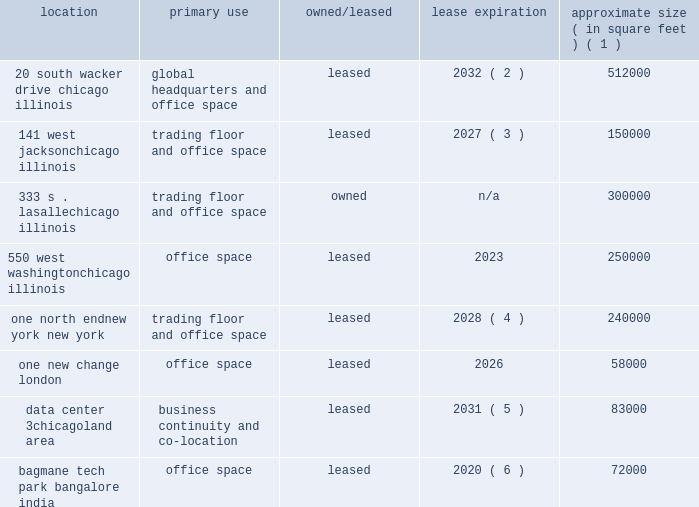Item 1b .
Unresolved staff comments not applicable .
Item 2 .
Properties our global headquarters are located in chicago , illinois , at 20 south wacker drive .
The following is a description of our key locations and facilities .
Location primary use owned/leased lease expiration approximate size ( in square feet ) ( 1 ) 20 south wacker drive chicago , illinois global headquarters and office space leased 2032 ( 2 ) 512000 141 west jackson chicago , illinois trading floor and office space leased 2027 ( 3 ) 150000 333 s .
Lasalle chicago , illinois trading floor and office space owned n/a 300000 550 west washington chicago , illinois office space leased 2023 250000 one north end new york , new york trading floor and office space leased 2028 ( 4 ) 240000 .
Data center 3 chicagoland area business continuity and co-location leased 2031 ( 5 ) 83000 bagmane tech park bangalore , office space leased 2020 ( 6 ) 72000 ( 1 ) size represents the amount of space leased or owned by us unless otherwise noted .
( 2 ) the initial lease expires in 2032 with two consecutive options to extend the term for five years each .
( 3 ) the initial lease expires in 2027 and contains options to extend the term and expand the premises .
( 4 ) the initial lease expires in 2028 and contains options to extend the term and expand the premises .
In 2019 , the premises will be reduced to 225000 square feet .
( 5 ) in march 2016 , the company sold its datacenter in the chicago area for $ 130.0 million .
At the time of the sale , the company leased back a portion of the property .
( 6 ) the initial lease expires in 2020 and contains an option to extend the term as well as an option to terminate early .
Item 3 .
Legal proceedings see 201clegal and regulatory matters 201d in note 12 .
Contingencies to the consolidated financial statements beginning on page 87 for cme group 2019s legal proceedings disclosure which is incorporated herein by reference .
Item 4 .
Mine safety disclosures not applicable. .
By what percentage will the space in one north endnew york new york decrease in 2019? 
Computations: ((225000 - 240000) / 240000)
Answer: -0.0625. 